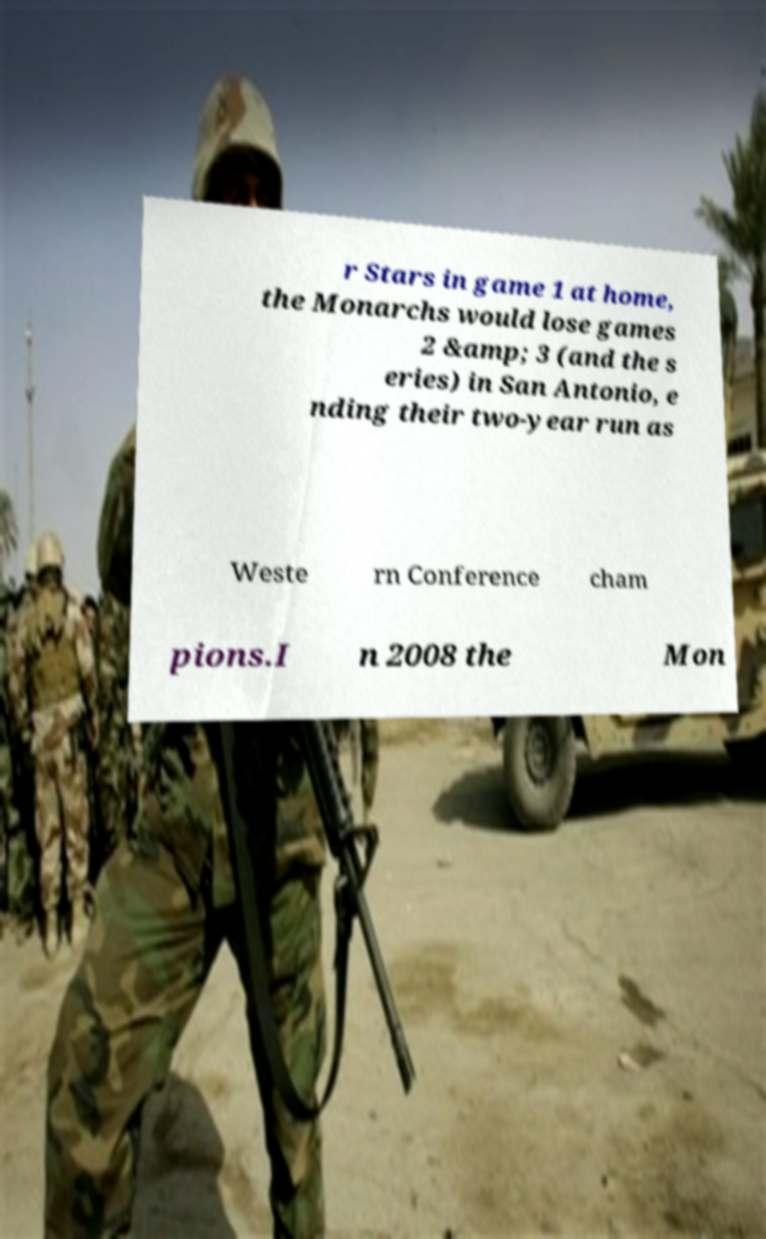Please identify and transcribe the text found in this image. r Stars in game 1 at home, the Monarchs would lose games 2 &amp; 3 (and the s eries) in San Antonio, e nding their two-year run as Weste rn Conference cham pions.I n 2008 the Mon 